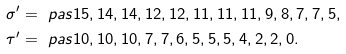<formula> <loc_0><loc_0><loc_500><loc_500>\sigma ^ { \prime } & = \ p a s { 1 5 , 1 4 , 1 4 , 1 2 , 1 2 , 1 1 , 1 1 , 1 1 , 9 , 8 , 7 , 7 , 5 } , \\ \tau ^ { \prime } & = \ p a s { 1 0 , 1 0 , 1 0 , 7 , 7 , 6 , 5 , 5 , 5 , 4 , 2 , 2 , 0 } .</formula> 